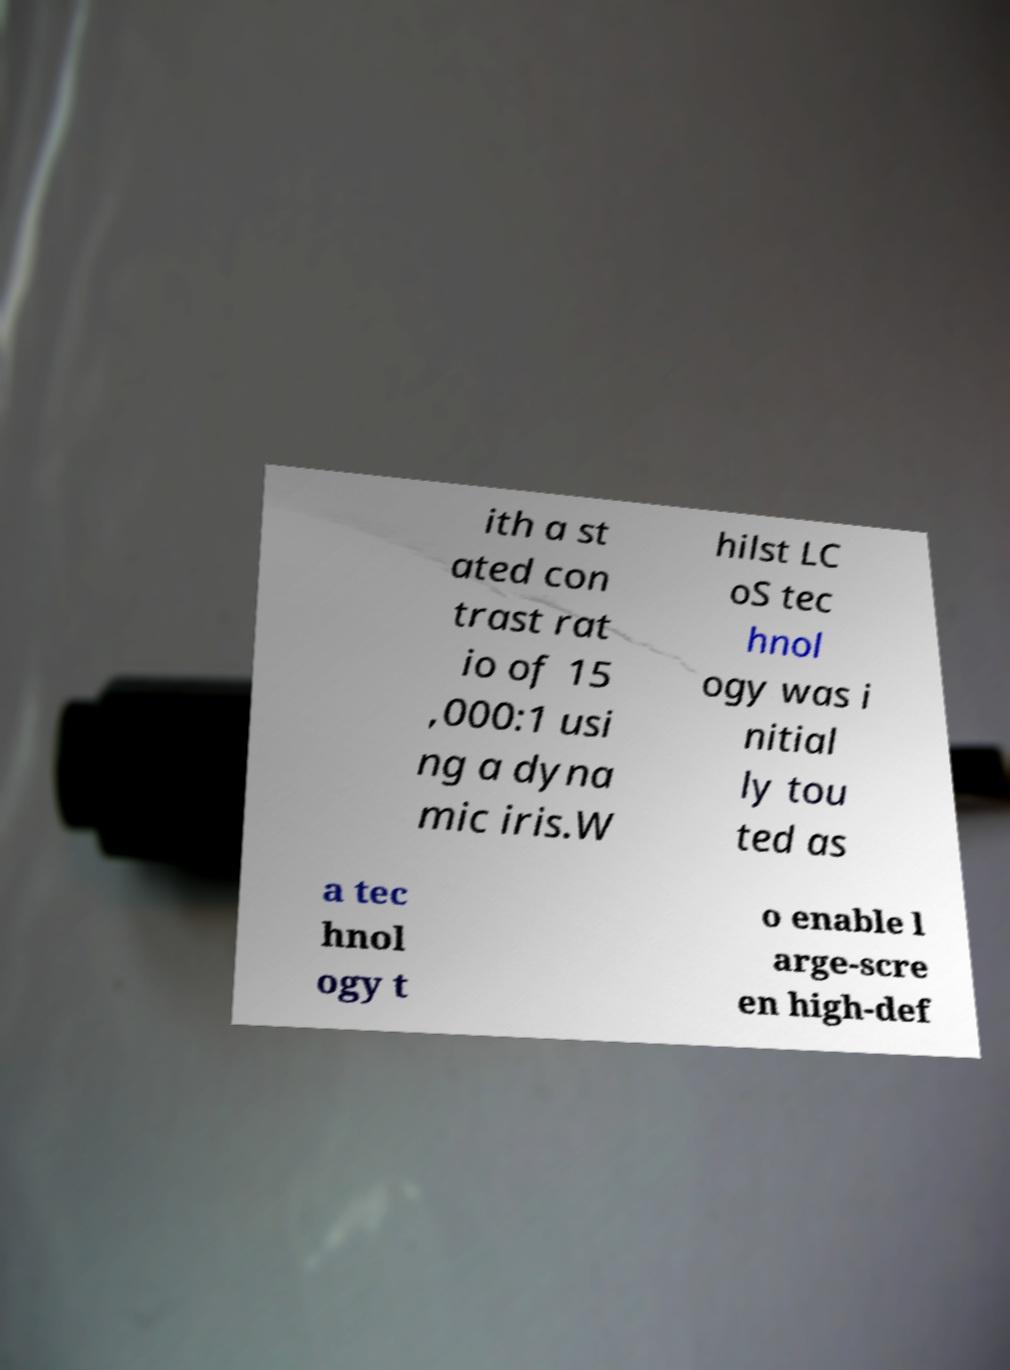I need the written content from this picture converted into text. Can you do that? ith a st ated con trast rat io of 15 ,000:1 usi ng a dyna mic iris.W hilst LC oS tec hnol ogy was i nitial ly tou ted as a tec hnol ogy t o enable l arge-scre en high-def 